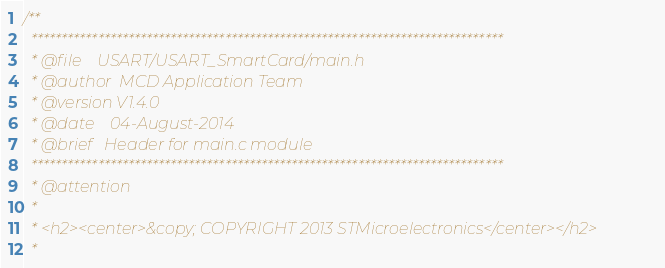Convert code to text. <code><loc_0><loc_0><loc_500><loc_500><_C_>/**
  ******************************************************************************
  * @file    USART/USART_SmartCard/main.h
  * @author  MCD Application Team
  * @version V1.4.0
  * @date    04-August-2014
  * @brief   Header for main.c module
  ******************************************************************************
  * @attention
  *
  * <h2><center>&copy; COPYRIGHT 2013 STMicroelectronics</center></h2>
  *</code> 